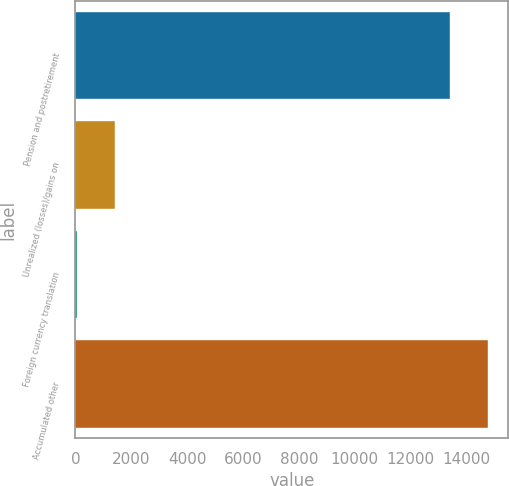Convert chart to OTSL. <chart><loc_0><loc_0><loc_500><loc_500><bar_chart><fcel>Pension and postretirement<fcel>Unrealized (losses)/gains on<fcel>Foreign currency translation<fcel>Accumulated other<nl><fcel>13421<fcel>1410.1<fcel>64<fcel>14767.1<nl></chart> 